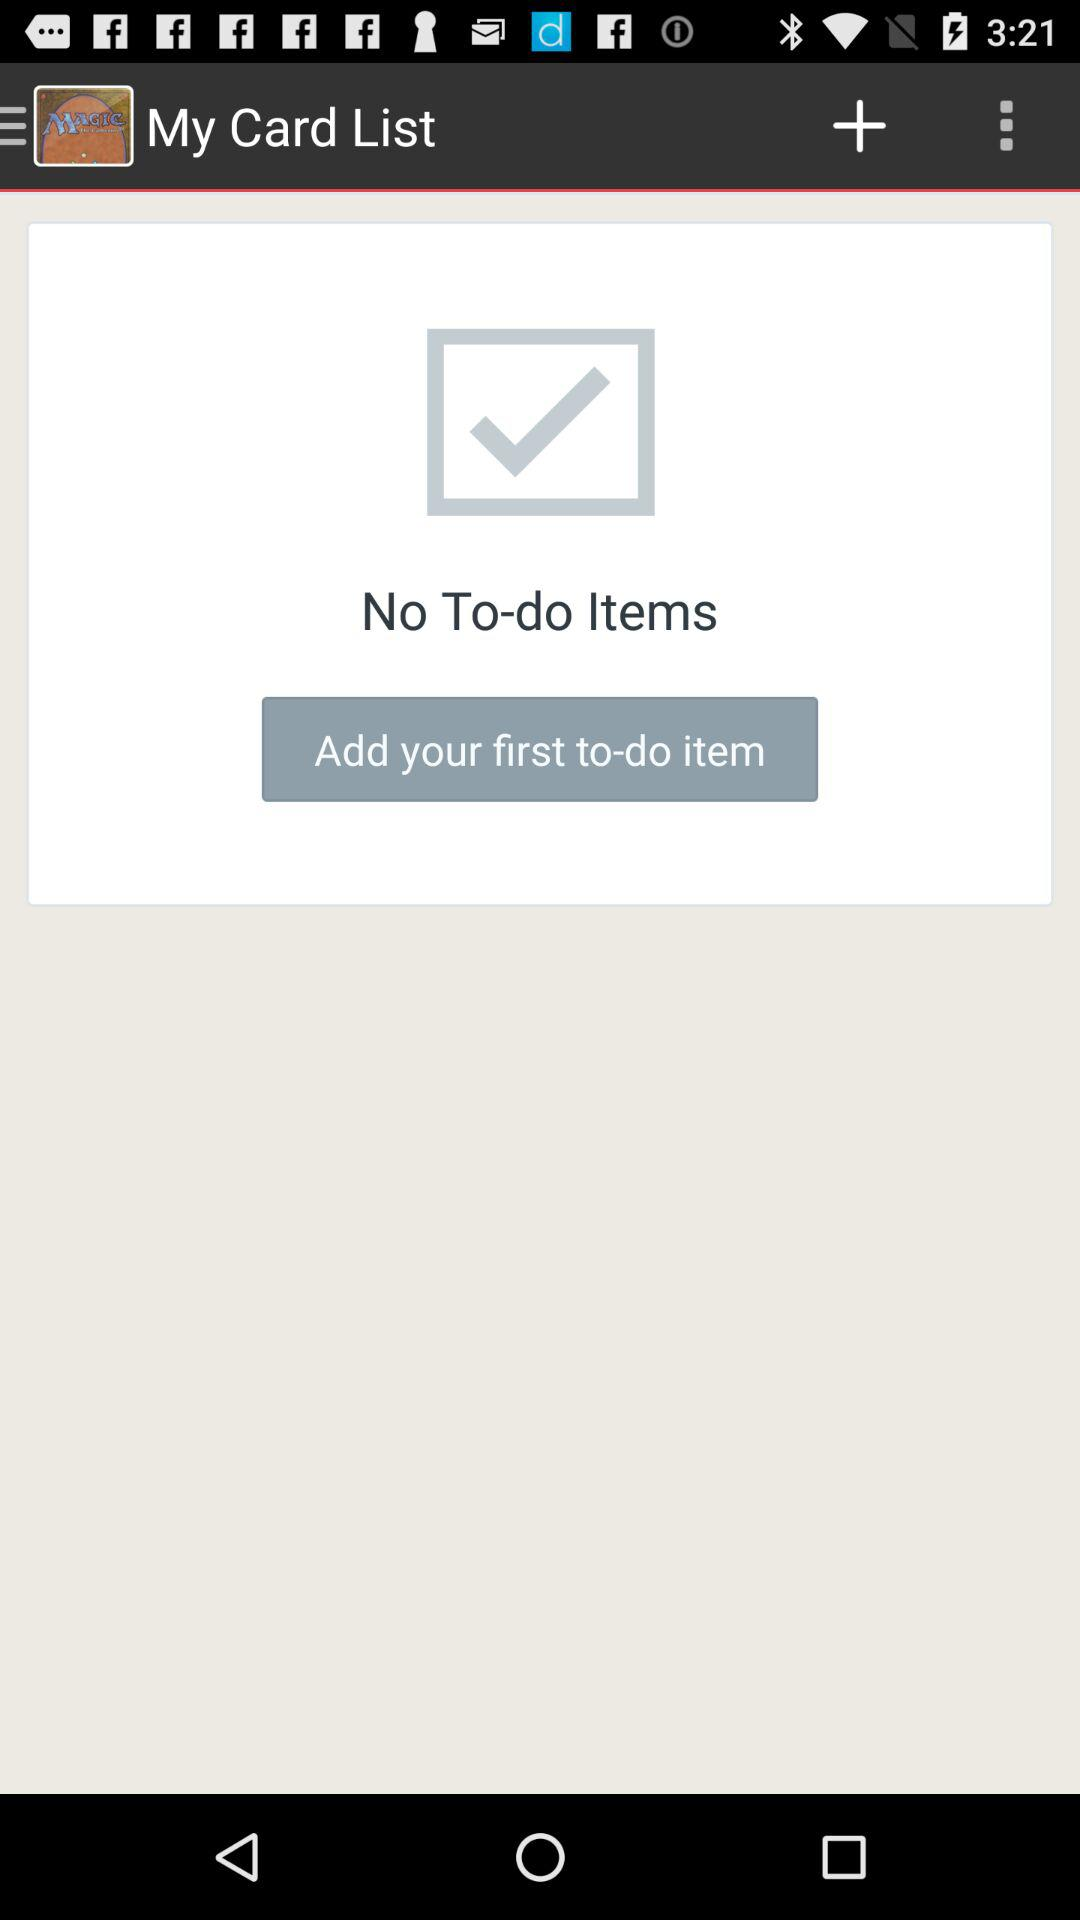Are there any to-do items? There are no to-do items. 